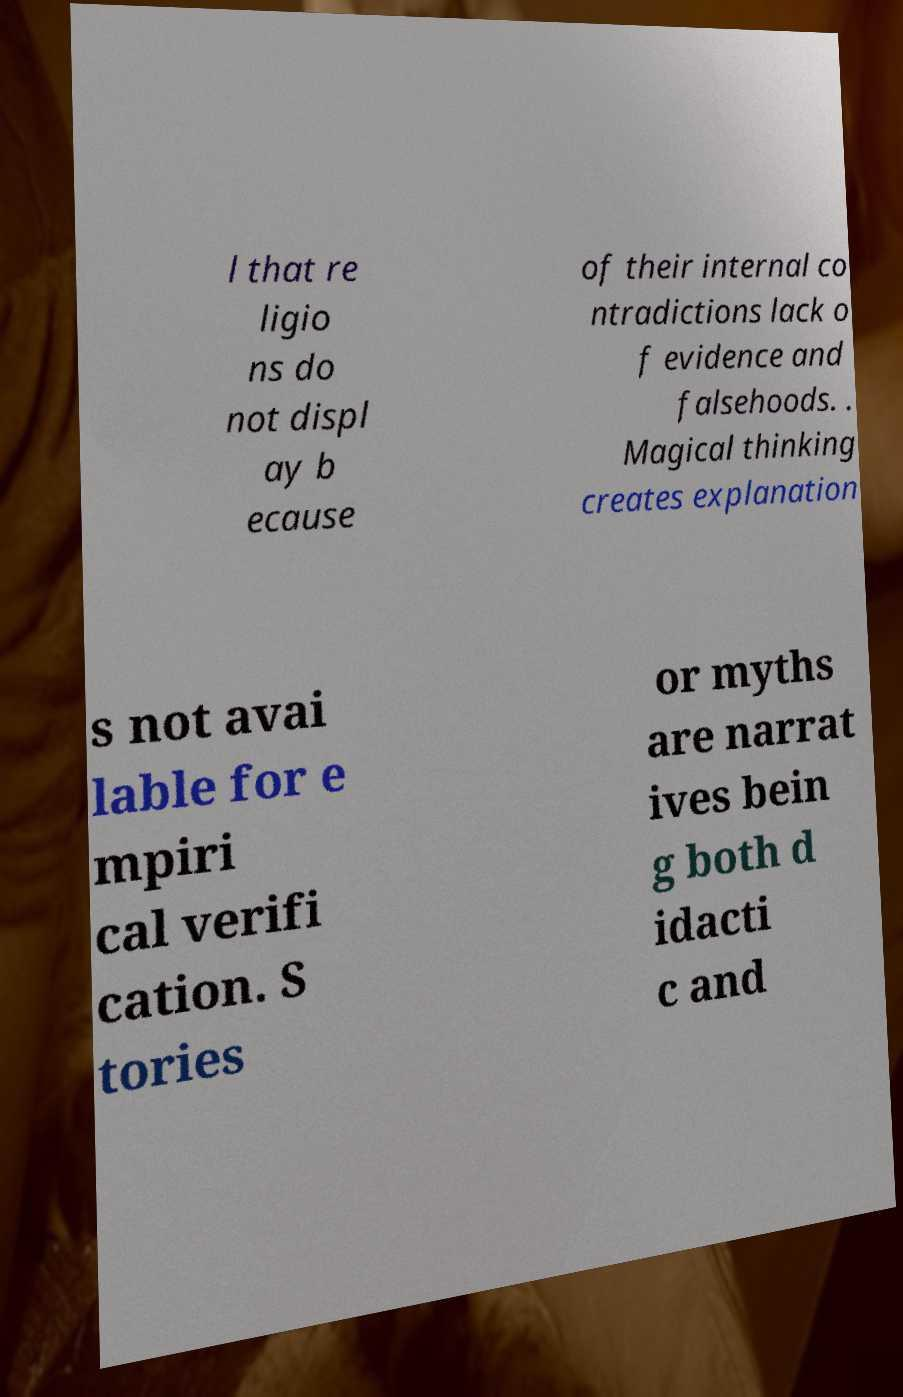Could you extract and type out the text from this image? l that re ligio ns do not displ ay b ecause of their internal co ntradictions lack o f evidence and falsehoods. . Magical thinking creates explanation s not avai lable for e mpiri cal verifi cation. S tories or myths are narrat ives bein g both d idacti c and 